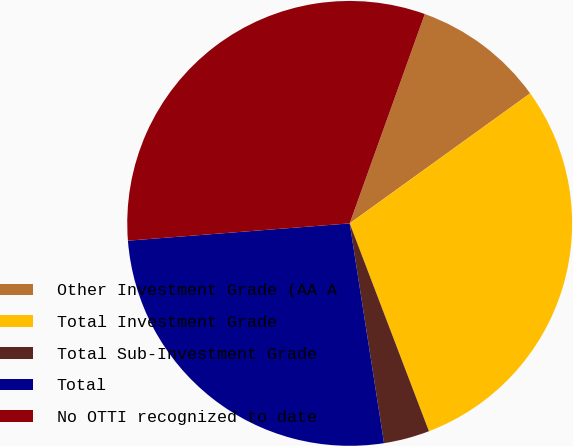Convert chart to OTSL. <chart><loc_0><loc_0><loc_500><loc_500><pie_chart><fcel>Other Investment Grade (AA A<fcel>Total Investment Grade<fcel>Total Sub-Investment Grade<fcel>Total<fcel>No OTTI recognized to date<nl><fcel>9.58%<fcel>29.14%<fcel>3.33%<fcel>26.23%<fcel>31.72%<nl></chart> 